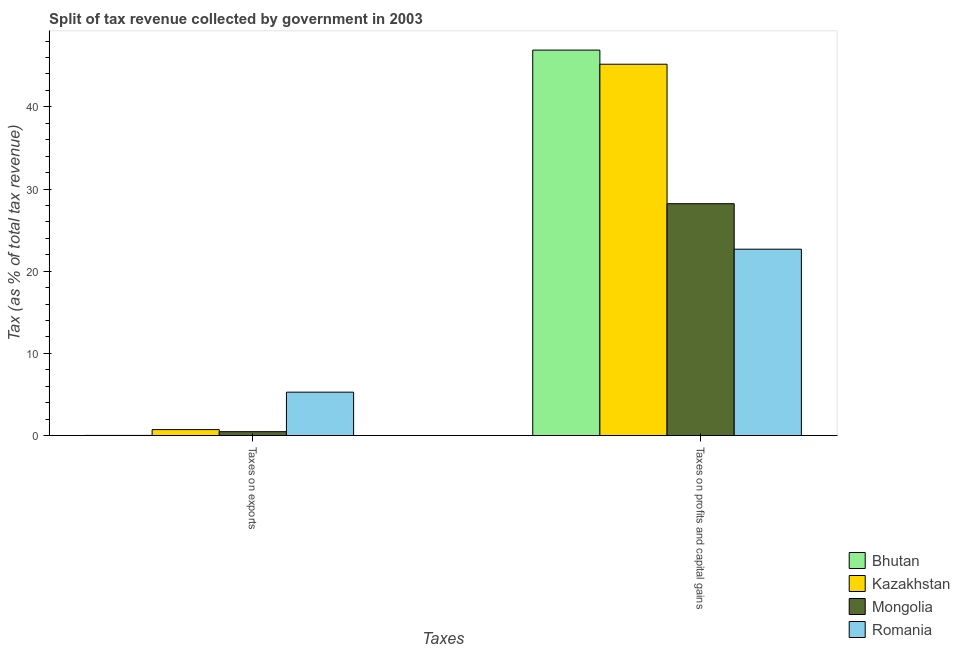How many different coloured bars are there?
Make the answer very short. 4. How many groups of bars are there?
Give a very brief answer. 2. Are the number of bars per tick equal to the number of legend labels?
Your answer should be compact. Yes. Are the number of bars on each tick of the X-axis equal?
Provide a succinct answer. Yes. How many bars are there on the 1st tick from the left?
Keep it short and to the point. 4. What is the label of the 2nd group of bars from the left?
Give a very brief answer. Taxes on profits and capital gains. What is the percentage of revenue obtained from taxes on exports in Bhutan?
Ensure brevity in your answer.  0.03. Across all countries, what is the maximum percentage of revenue obtained from taxes on exports?
Make the answer very short. 5.29. Across all countries, what is the minimum percentage of revenue obtained from taxes on profits and capital gains?
Ensure brevity in your answer.  22.68. In which country was the percentage of revenue obtained from taxes on exports maximum?
Give a very brief answer. Romania. In which country was the percentage of revenue obtained from taxes on exports minimum?
Provide a short and direct response. Bhutan. What is the total percentage of revenue obtained from taxes on profits and capital gains in the graph?
Your answer should be compact. 142.98. What is the difference between the percentage of revenue obtained from taxes on profits and capital gains in Romania and that in Mongolia?
Offer a terse response. -5.53. What is the difference between the percentage of revenue obtained from taxes on exports in Romania and the percentage of revenue obtained from taxes on profits and capital gains in Bhutan?
Ensure brevity in your answer.  -41.61. What is the average percentage of revenue obtained from taxes on exports per country?
Provide a short and direct response. 1.63. What is the difference between the percentage of revenue obtained from taxes on exports and percentage of revenue obtained from taxes on profits and capital gains in Kazakhstan?
Make the answer very short. -44.45. What is the ratio of the percentage of revenue obtained from taxes on profits and capital gains in Bhutan to that in Kazakhstan?
Provide a succinct answer. 1.04. In how many countries, is the percentage of revenue obtained from taxes on exports greater than the average percentage of revenue obtained from taxes on exports taken over all countries?
Provide a succinct answer. 1. What does the 3rd bar from the left in Taxes on profits and capital gains represents?
Your response must be concise. Mongolia. What does the 4th bar from the right in Taxes on profits and capital gains represents?
Provide a succinct answer. Bhutan. How many countries are there in the graph?
Offer a terse response. 4. Does the graph contain any zero values?
Make the answer very short. No. Where does the legend appear in the graph?
Your answer should be compact. Bottom right. How many legend labels are there?
Offer a very short reply. 4. How are the legend labels stacked?
Offer a very short reply. Vertical. What is the title of the graph?
Provide a short and direct response. Split of tax revenue collected by government in 2003. Does "Euro area" appear as one of the legend labels in the graph?
Provide a succinct answer. No. What is the label or title of the X-axis?
Make the answer very short. Taxes. What is the label or title of the Y-axis?
Provide a succinct answer. Tax (as % of total tax revenue). What is the Tax (as % of total tax revenue) of Bhutan in Taxes on exports?
Offer a very short reply. 0.03. What is the Tax (as % of total tax revenue) of Kazakhstan in Taxes on exports?
Offer a very short reply. 0.73. What is the Tax (as % of total tax revenue) of Mongolia in Taxes on exports?
Your response must be concise. 0.48. What is the Tax (as % of total tax revenue) in Romania in Taxes on exports?
Offer a very short reply. 5.29. What is the Tax (as % of total tax revenue) in Bhutan in Taxes on profits and capital gains?
Offer a very short reply. 46.9. What is the Tax (as % of total tax revenue) in Kazakhstan in Taxes on profits and capital gains?
Offer a very short reply. 45.18. What is the Tax (as % of total tax revenue) in Mongolia in Taxes on profits and capital gains?
Provide a succinct answer. 28.21. What is the Tax (as % of total tax revenue) in Romania in Taxes on profits and capital gains?
Keep it short and to the point. 22.68. Across all Taxes, what is the maximum Tax (as % of total tax revenue) in Bhutan?
Offer a very short reply. 46.9. Across all Taxes, what is the maximum Tax (as % of total tax revenue) in Kazakhstan?
Your answer should be compact. 45.18. Across all Taxes, what is the maximum Tax (as % of total tax revenue) of Mongolia?
Ensure brevity in your answer.  28.21. Across all Taxes, what is the maximum Tax (as % of total tax revenue) of Romania?
Make the answer very short. 22.68. Across all Taxes, what is the minimum Tax (as % of total tax revenue) of Bhutan?
Give a very brief answer. 0.03. Across all Taxes, what is the minimum Tax (as % of total tax revenue) in Kazakhstan?
Your answer should be compact. 0.73. Across all Taxes, what is the minimum Tax (as % of total tax revenue) of Mongolia?
Offer a terse response. 0.48. Across all Taxes, what is the minimum Tax (as % of total tax revenue) of Romania?
Provide a succinct answer. 5.29. What is the total Tax (as % of total tax revenue) in Bhutan in the graph?
Make the answer very short. 46.93. What is the total Tax (as % of total tax revenue) in Kazakhstan in the graph?
Keep it short and to the point. 45.92. What is the total Tax (as % of total tax revenue) of Mongolia in the graph?
Offer a terse response. 28.7. What is the total Tax (as % of total tax revenue) in Romania in the graph?
Give a very brief answer. 27.97. What is the difference between the Tax (as % of total tax revenue) of Bhutan in Taxes on exports and that in Taxes on profits and capital gains?
Give a very brief answer. -46.87. What is the difference between the Tax (as % of total tax revenue) of Kazakhstan in Taxes on exports and that in Taxes on profits and capital gains?
Keep it short and to the point. -44.45. What is the difference between the Tax (as % of total tax revenue) of Mongolia in Taxes on exports and that in Taxes on profits and capital gains?
Ensure brevity in your answer.  -27.73. What is the difference between the Tax (as % of total tax revenue) in Romania in Taxes on exports and that in Taxes on profits and capital gains?
Provide a short and direct response. -17.39. What is the difference between the Tax (as % of total tax revenue) of Bhutan in Taxes on exports and the Tax (as % of total tax revenue) of Kazakhstan in Taxes on profits and capital gains?
Give a very brief answer. -45.15. What is the difference between the Tax (as % of total tax revenue) of Bhutan in Taxes on exports and the Tax (as % of total tax revenue) of Mongolia in Taxes on profits and capital gains?
Your answer should be very brief. -28.19. What is the difference between the Tax (as % of total tax revenue) of Bhutan in Taxes on exports and the Tax (as % of total tax revenue) of Romania in Taxes on profits and capital gains?
Ensure brevity in your answer.  -22.65. What is the difference between the Tax (as % of total tax revenue) in Kazakhstan in Taxes on exports and the Tax (as % of total tax revenue) in Mongolia in Taxes on profits and capital gains?
Make the answer very short. -27.48. What is the difference between the Tax (as % of total tax revenue) in Kazakhstan in Taxes on exports and the Tax (as % of total tax revenue) in Romania in Taxes on profits and capital gains?
Offer a terse response. -21.95. What is the difference between the Tax (as % of total tax revenue) of Mongolia in Taxes on exports and the Tax (as % of total tax revenue) of Romania in Taxes on profits and capital gains?
Your answer should be compact. -22.2. What is the average Tax (as % of total tax revenue) of Bhutan per Taxes?
Make the answer very short. 23.46. What is the average Tax (as % of total tax revenue) of Kazakhstan per Taxes?
Your response must be concise. 22.96. What is the average Tax (as % of total tax revenue) of Mongolia per Taxes?
Ensure brevity in your answer.  14.35. What is the average Tax (as % of total tax revenue) in Romania per Taxes?
Keep it short and to the point. 13.99. What is the difference between the Tax (as % of total tax revenue) in Bhutan and Tax (as % of total tax revenue) in Kazakhstan in Taxes on exports?
Make the answer very short. -0.71. What is the difference between the Tax (as % of total tax revenue) of Bhutan and Tax (as % of total tax revenue) of Mongolia in Taxes on exports?
Keep it short and to the point. -0.45. What is the difference between the Tax (as % of total tax revenue) of Bhutan and Tax (as % of total tax revenue) of Romania in Taxes on exports?
Your answer should be compact. -5.26. What is the difference between the Tax (as % of total tax revenue) of Kazakhstan and Tax (as % of total tax revenue) of Mongolia in Taxes on exports?
Ensure brevity in your answer.  0.25. What is the difference between the Tax (as % of total tax revenue) of Kazakhstan and Tax (as % of total tax revenue) of Romania in Taxes on exports?
Ensure brevity in your answer.  -4.55. What is the difference between the Tax (as % of total tax revenue) in Mongolia and Tax (as % of total tax revenue) in Romania in Taxes on exports?
Provide a succinct answer. -4.81. What is the difference between the Tax (as % of total tax revenue) of Bhutan and Tax (as % of total tax revenue) of Kazakhstan in Taxes on profits and capital gains?
Keep it short and to the point. 1.72. What is the difference between the Tax (as % of total tax revenue) in Bhutan and Tax (as % of total tax revenue) in Mongolia in Taxes on profits and capital gains?
Give a very brief answer. 18.69. What is the difference between the Tax (as % of total tax revenue) in Bhutan and Tax (as % of total tax revenue) in Romania in Taxes on profits and capital gains?
Provide a short and direct response. 24.22. What is the difference between the Tax (as % of total tax revenue) of Kazakhstan and Tax (as % of total tax revenue) of Mongolia in Taxes on profits and capital gains?
Offer a very short reply. 16.97. What is the difference between the Tax (as % of total tax revenue) of Kazakhstan and Tax (as % of total tax revenue) of Romania in Taxes on profits and capital gains?
Make the answer very short. 22.5. What is the difference between the Tax (as % of total tax revenue) of Mongolia and Tax (as % of total tax revenue) of Romania in Taxes on profits and capital gains?
Your answer should be compact. 5.53. What is the ratio of the Tax (as % of total tax revenue) of Bhutan in Taxes on exports to that in Taxes on profits and capital gains?
Your response must be concise. 0. What is the ratio of the Tax (as % of total tax revenue) in Kazakhstan in Taxes on exports to that in Taxes on profits and capital gains?
Provide a short and direct response. 0.02. What is the ratio of the Tax (as % of total tax revenue) in Mongolia in Taxes on exports to that in Taxes on profits and capital gains?
Your answer should be compact. 0.02. What is the ratio of the Tax (as % of total tax revenue) in Romania in Taxes on exports to that in Taxes on profits and capital gains?
Your answer should be compact. 0.23. What is the difference between the highest and the second highest Tax (as % of total tax revenue) of Bhutan?
Ensure brevity in your answer.  46.87. What is the difference between the highest and the second highest Tax (as % of total tax revenue) of Kazakhstan?
Provide a short and direct response. 44.45. What is the difference between the highest and the second highest Tax (as % of total tax revenue) of Mongolia?
Offer a very short reply. 27.73. What is the difference between the highest and the second highest Tax (as % of total tax revenue) in Romania?
Provide a short and direct response. 17.39. What is the difference between the highest and the lowest Tax (as % of total tax revenue) of Bhutan?
Ensure brevity in your answer.  46.87. What is the difference between the highest and the lowest Tax (as % of total tax revenue) of Kazakhstan?
Offer a terse response. 44.45. What is the difference between the highest and the lowest Tax (as % of total tax revenue) in Mongolia?
Give a very brief answer. 27.73. What is the difference between the highest and the lowest Tax (as % of total tax revenue) in Romania?
Offer a terse response. 17.39. 